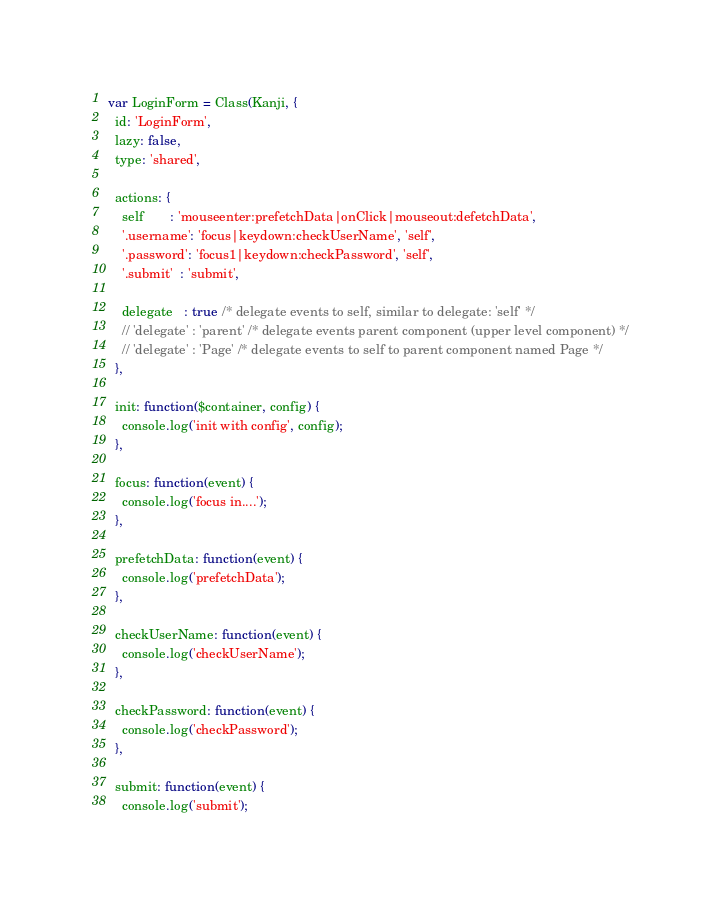<code> <loc_0><loc_0><loc_500><loc_500><_JavaScript_>var LoginForm = Class(Kanji, {
  id: 'LoginForm',
  lazy: false,
  type: 'shared',

  actions: {
    self       : 'mouseenter:prefetchData|onClick|mouseout:defetchData',
    '.username': 'focus|keydown:checkUserName', 'self',
    '.password': 'focus1|keydown:checkPassword', 'self',
    '.submit'  : 'submit',

    delegate   : true /* delegate events to self, similar to delegate: 'self' */
    // 'delegate' : 'parent' /* delegate events parent component (upper level component) */
    // 'delegate' : 'Page' /* delegate events to self to parent component named Page */
  },

  init: function($container, config) {
    console.log('init with config', config);
  },

  focus: function(event) {
    console.log('focus in....');
  },

  prefetchData: function(event) {
    console.log('prefetchData');
  },

  checkUserName: function(event) {
    console.log('checkUserName');
  },

  checkPassword: function(event) {
    console.log('checkPassword');
  },

  submit: function(event) {
    console.log('submit');</code> 